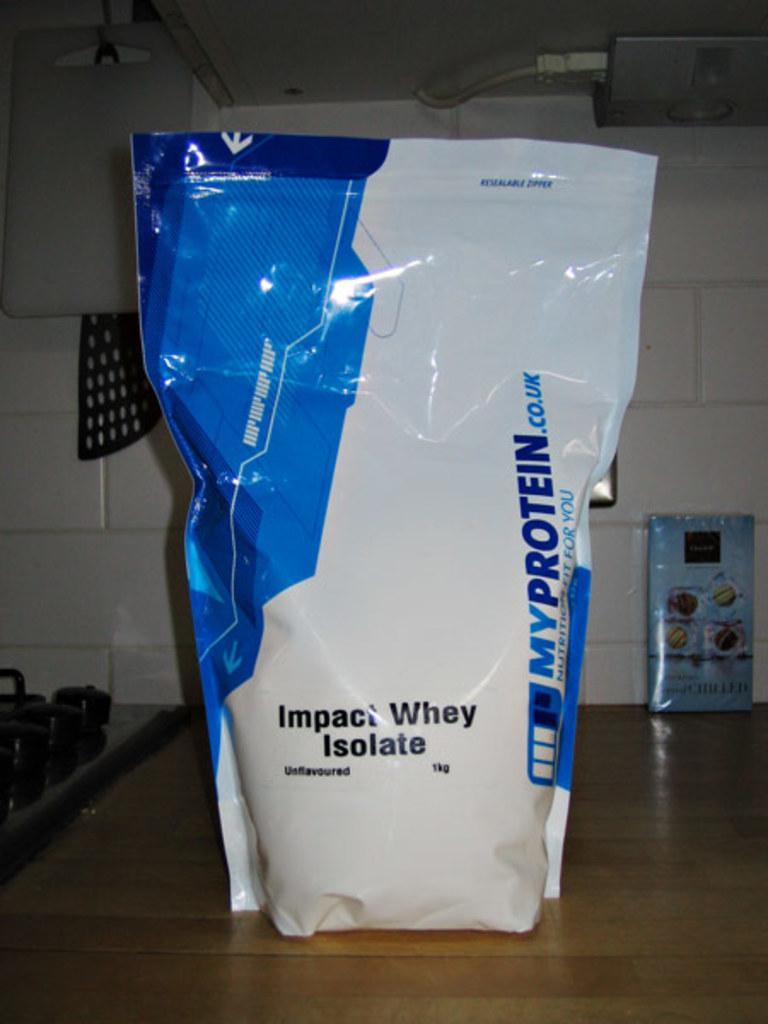How would you summarize this image in a sentence or two? In this image I can see the packet which is in white and blue color. And there is a name my protein is written on it. It is on the brown color surface. To the left I can see the black color object. In the background I can see the white wall and there is a blue color board can be seen. 